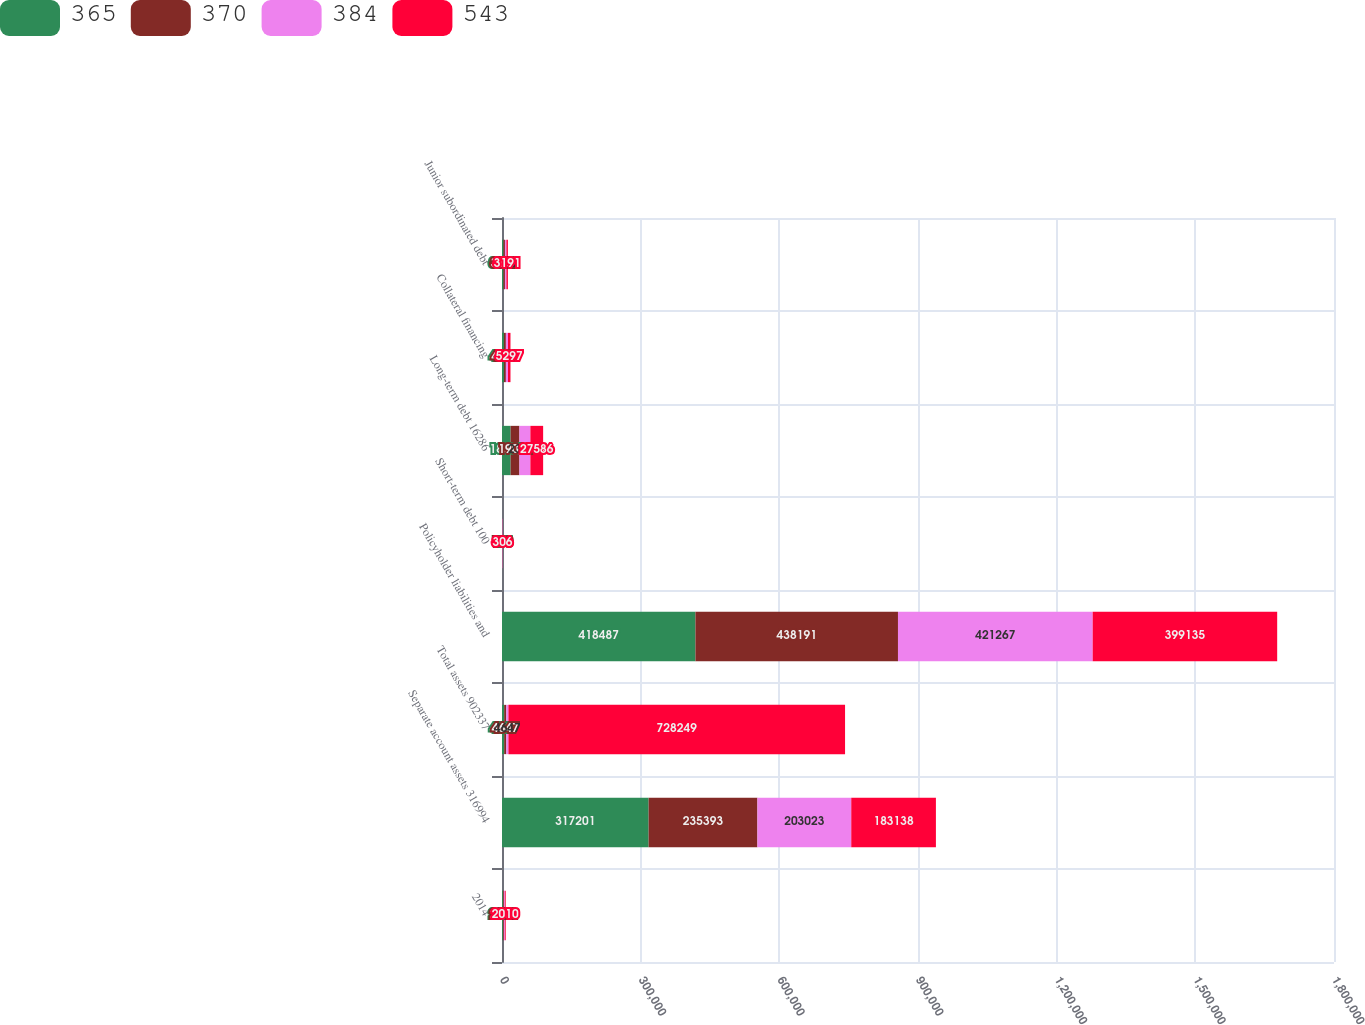Convert chart. <chart><loc_0><loc_0><loc_500><loc_500><stacked_bar_chart><ecel><fcel>2014<fcel>Separate account assets 316994<fcel>Total assets 902337<fcel>Policyholder liabilities and<fcel>Short-term debt 100<fcel>Long-term debt 16286<fcel>Collateral financing<fcel>Junior subordinated debt<nl><fcel>365<fcel>2013<fcel>317201<fcel>4647<fcel>418487<fcel>175<fcel>18653<fcel>4196<fcel>3193<nl><fcel>370<fcel>2012<fcel>235393<fcel>4647<fcel>438191<fcel>100<fcel>19062<fcel>4196<fcel>3192<nl><fcel>384<fcel>2011<fcel>203023<fcel>4647<fcel>421267<fcel>686<fcel>23692<fcel>4647<fcel>3192<nl><fcel>543<fcel>2010<fcel>183138<fcel>728249<fcel>399135<fcel>306<fcel>27586<fcel>5297<fcel>3191<nl></chart> 